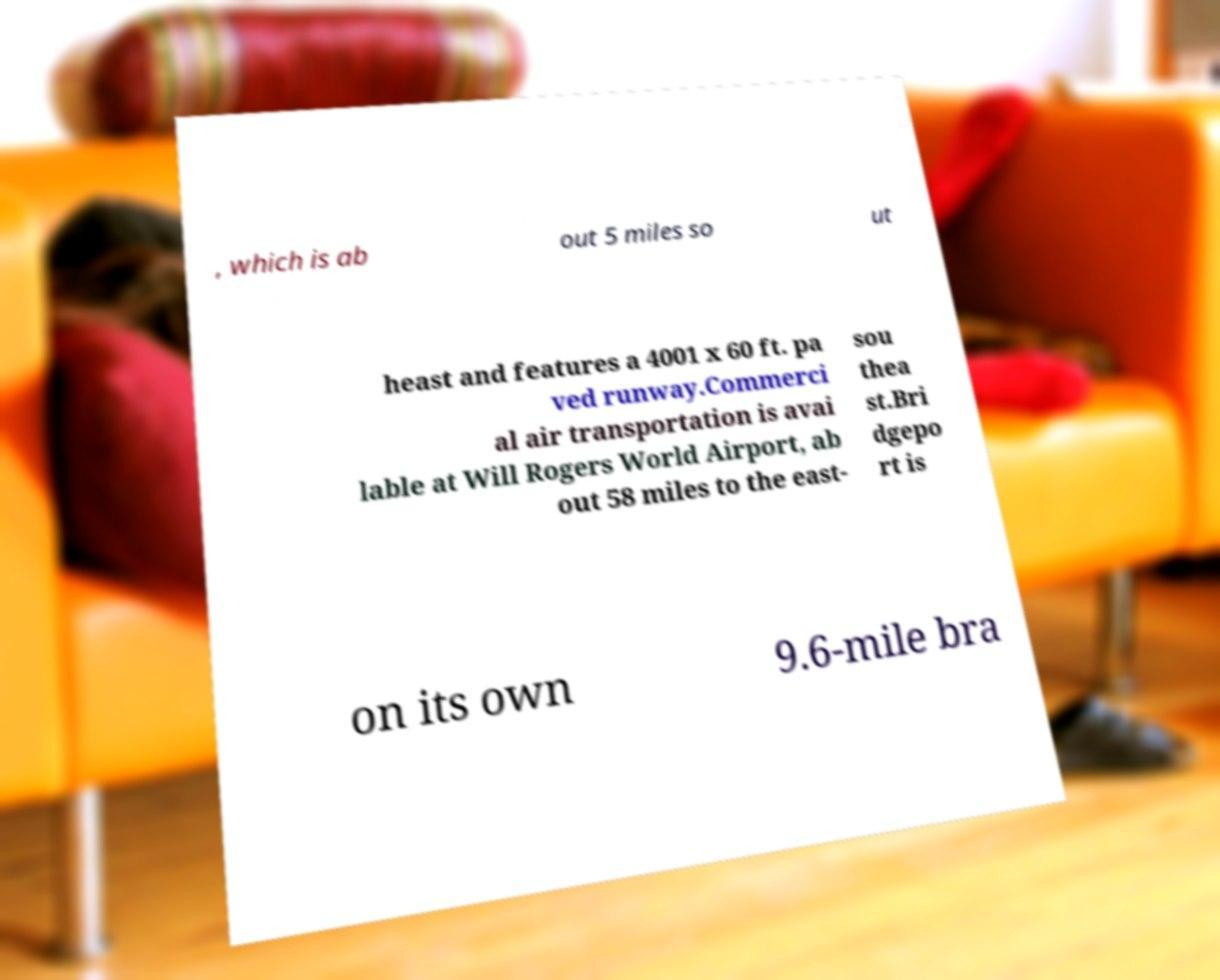I need the written content from this picture converted into text. Can you do that? , which is ab out 5 miles so ut heast and features a 4001 x 60 ft. pa ved runway.Commerci al air transportation is avai lable at Will Rogers World Airport, ab out 58 miles to the east- sou thea st.Bri dgepo rt is on its own 9.6-mile bra 